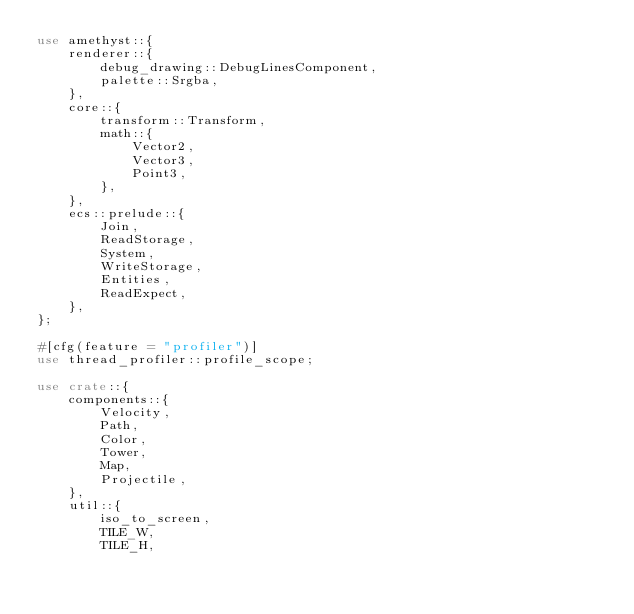Convert code to text. <code><loc_0><loc_0><loc_500><loc_500><_Rust_>use amethyst::{
    renderer::{
        debug_drawing::DebugLinesComponent,
        palette::Srgba,
    },
    core::{
        transform::Transform,
        math::{
            Vector2,
            Vector3,
            Point3,
        },
    },
    ecs::prelude::{
        Join,
        ReadStorage, 
        System, 
        WriteStorage, 
        Entities,
        ReadExpect,
    },
};

#[cfg(feature = "profiler")]
use thread_profiler::profile_scope;

use crate::{
    components::{
        Velocity,
        Path,
        Color,
        Tower,
        Map,
        Projectile,
    },
    util::{
        iso_to_screen,
        TILE_W,
        TILE_H,</code> 